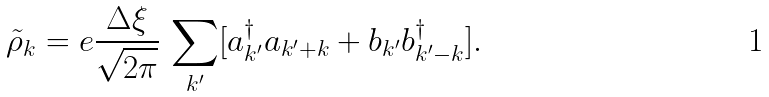Convert formula to latex. <formula><loc_0><loc_0><loc_500><loc_500>\tilde { \rho } _ { k } = e \frac { \Delta \xi } { \sqrt { 2 \pi } } \, \sum _ { k ^ { \prime } } [ a ^ { \dagger } _ { k ^ { \prime } } a _ { k ^ { \prime } + k } + b _ { k ^ { \prime } } b ^ { \dagger } _ { k ^ { \prime } - k } ] .</formula> 